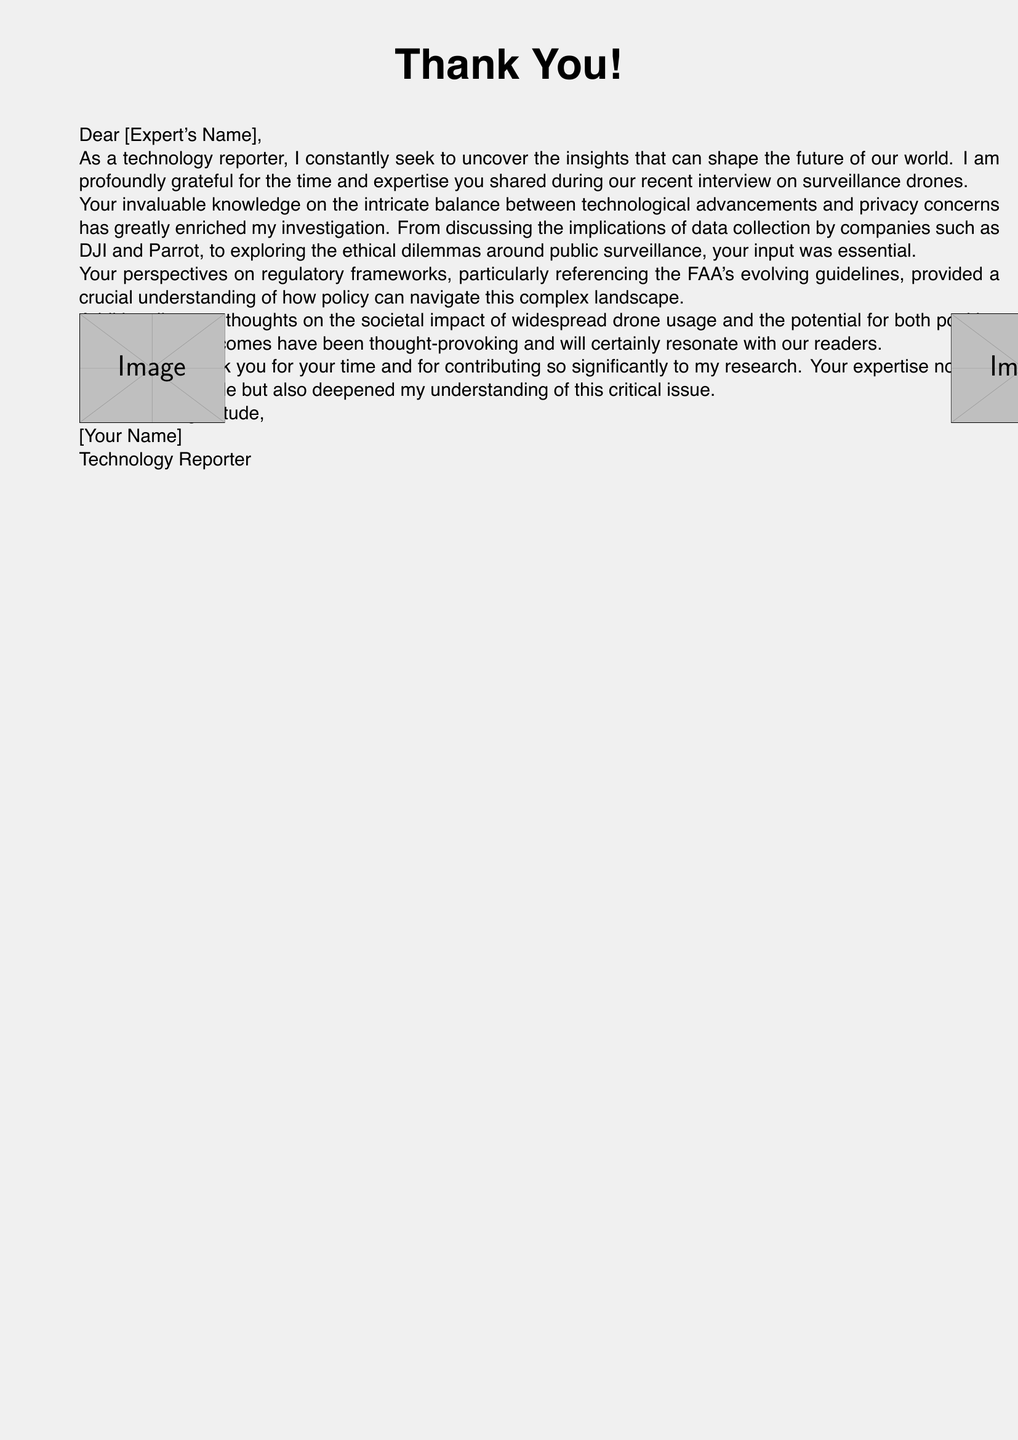What is the title of the card? The title is prominently displayed at the top of the card, which indicates gratitude.
Answer: Thank You! Who is the letter addressed to? The letter includes a placeholder for the name of the recipient, indicating to whom the gratitude is directed.
Answer: [Expert's Name] What profession does the sender identify with? The sender clearly states their profession in the closing of the letter.
Answer: Technology Reporter Which companies are mentioned in the document? The text includes references to specific companies known for their drone technology.
Answer: DJI and Parrot What regulatory bodies are referenced in the card? The document discusses guidelines set by certain regulatory frameworks concerning drone usage.
Answer: FAA What type of content is primarily discussed in the interview? The overall theme focuses on the implications of a certain technology in society.
Answer: Surveillance drones What is the purpose of the card? The primary aim of the card is to express appreciation for the recipient's contributions.
Answer: To express gratitude What visual elements are represented in the card? The card includes images that symbolize the subject matter discussed in the content.
Answer: Magnifying glass and drone icon 